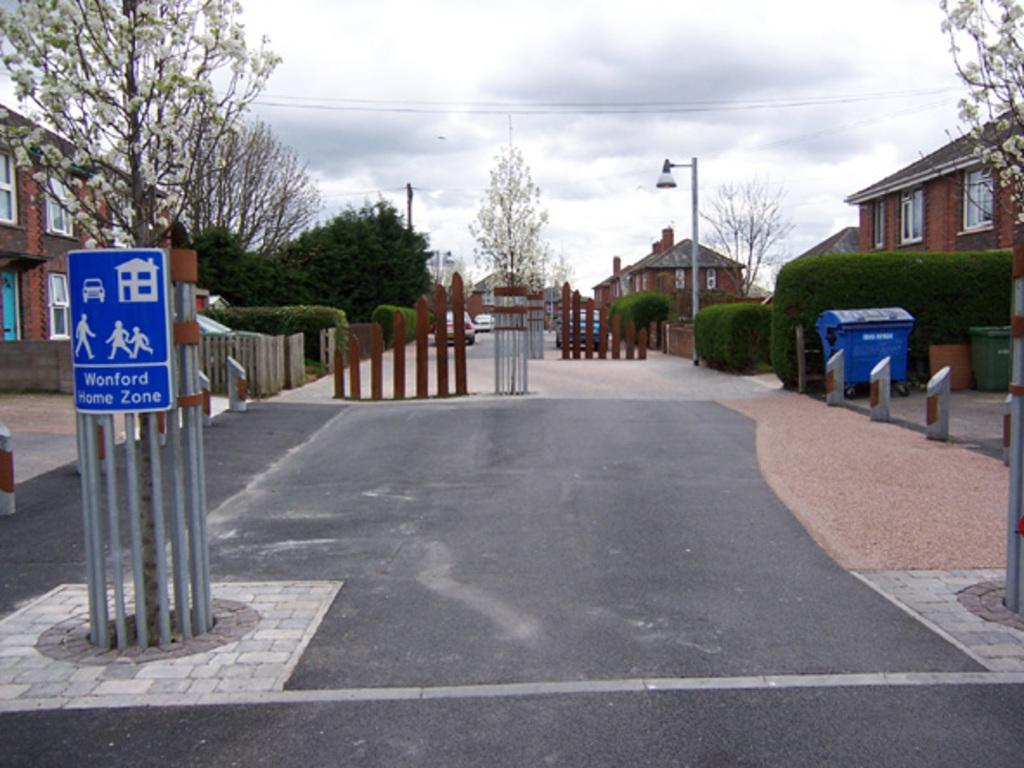<image>
Offer a succinct explanation of the picture presented. the word wonford that is on a sign 